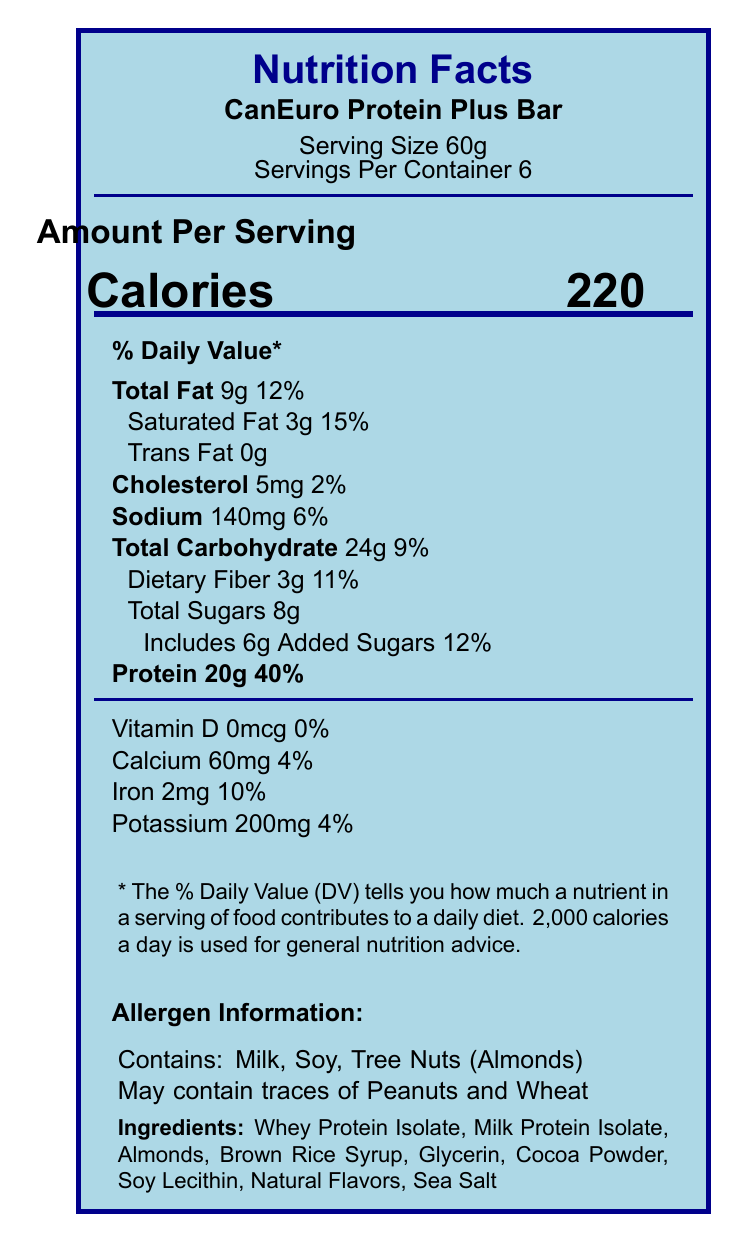what is the serving size of the CanEuro Protein Plus Bar? The document states that the serving size is 60g.
Answer: 60g what is the daily value percentage of protein per serving? The nutrition facts label indicates that the protein content per serving has a daily value of 40%.
Answer: 40% how much saturated fat is in one serving? The amount of saturated fat per serving is listed as 3g.
Answer: 3g what allergens does the CanEuro Protein Plus Bar contain? The allergen information section indicates that the bar contains Milk, Soy, and Tree Nuts (Almonds).
Answer: Milk, Soy, Tree Nuts (Almonds) what additional allergens might be present due to cross-contamination? The label indicates that the bar may contain traces of Peanuts and Wheat.
Answer: Peanuts and Wheat how many calories are in each serving? The document states that each serving contains 220 calories.
Answer: 220 what is the total carbohydrate content per serving? The label indicates 24g of total carbohydrates per serving.
Answer: 24g which company manufactures the CanEuro Protein Plus Bar? A. EuroProtein GmbH B. NutriTech Foods Inc. C. Health Canada D. Non-GMO Project Verified The document lists NutriTech Foods Inc. as the manufacturer.
Answer: B the CanEuro Protein Plus Bar is high in which nutrient? A. Fat B. Protein C. Carbohydrates D. Fiber The document claims that the bar is high in protein.
Answer: B does the CanEuro Protein Plus Bar contain any artificial preservatives? The additional label claims indicate that there are no artificial preservatives.
Answer: No summarize the key information provided in the Nutrition Facts label and associated details. The document provides nutritional details, allergen information, manufacturer details, compliance, and certifications.
Answer: The Nutrition Facts label for the CanEuro Protein Plus Bar includes the serving size (60g), servings per container (6), and key nutritional information such as calories (220), total fat (9g), protein (20g), and various vitamins and minerals. The allergen information notes that the product contains Milk, Soy, and Tree Nuts (Almonds), and may contain traces of Peanuts and Wheat. The bar is manufactured by NutriTech Foods Inc. in Toronto, Canada, in partnership with EuroProtein GmbH in Berlin, Germany. It is compliant with both EU and Canadian nutrition regulations and has several certifications including Health Canada Approved and EU Organic Certified. what is the country of origin for the CanEuro Protein Plus Bar? The visual document provides manufacturing locations but does not specify the country of origin definitively. The manufacturing involves both Canada and Germany.
Answer: Not enough information is the CanEuro Protein Plus Bar organic certified? The document states that the bar is EU Organic Certified.
Answer: Yes 